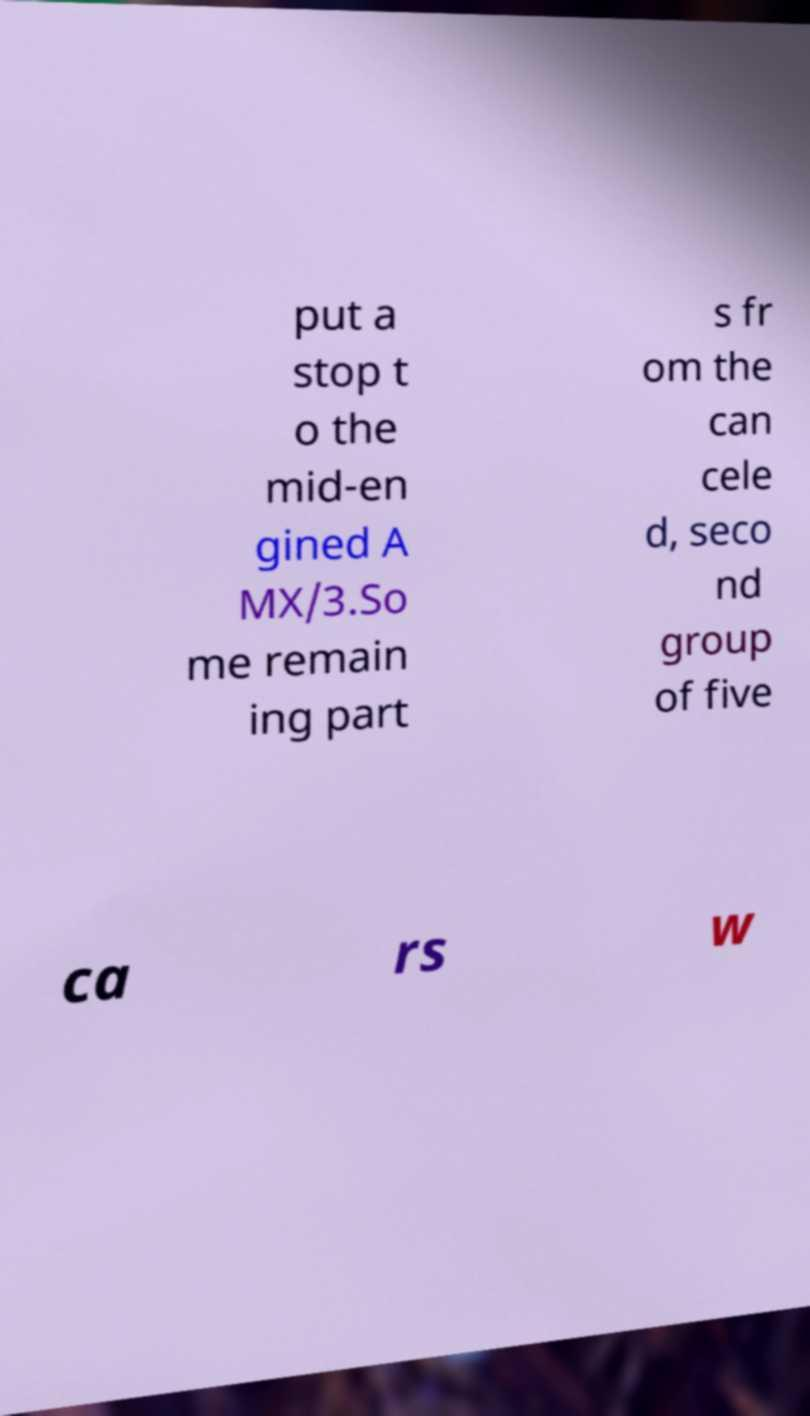Could you extract and type out the text from this image? put a stop t o the mid-en gined A MX/3.So me remain ing part s fr om the can cele d, seco nd group of five ca rs w 